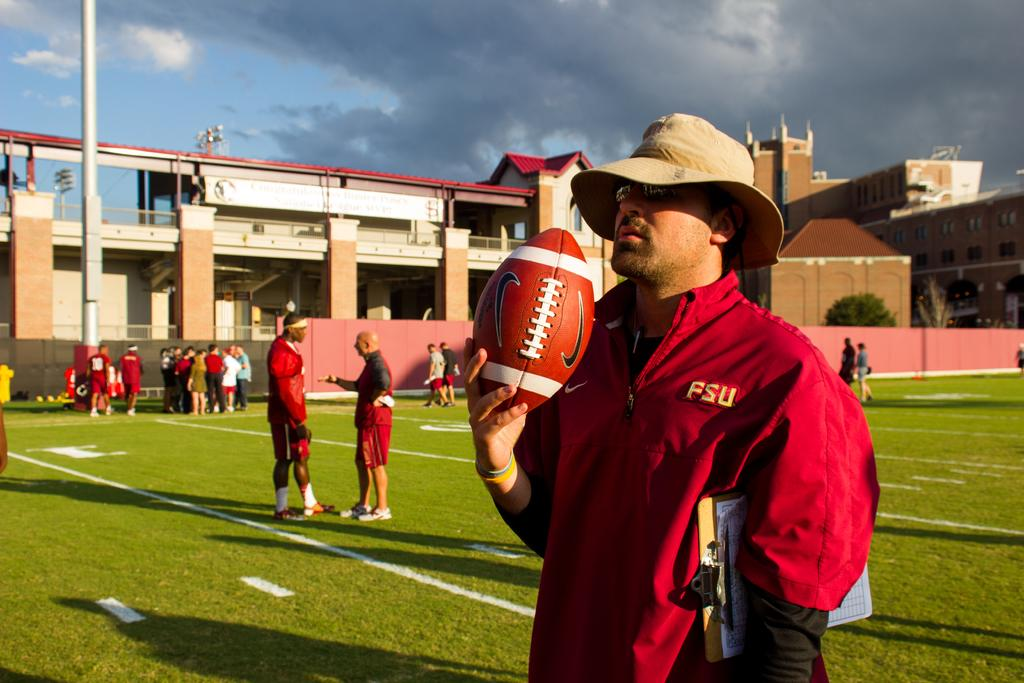How many individuals are present in the image? There are many people in the image. Where are the people located? The people are in a ground in the image. What structure can be seen in the image? There is a building in the image. What other object is present in the image? There is a pole in the image. What is the weather like in the image? The sky is cloudy in the image. What type of table is being used by the people in the image? There is no table present in the image; the people are in a ground. Can you see a knife being used by any of the individuals in the image? There is no knife visible in the image. 